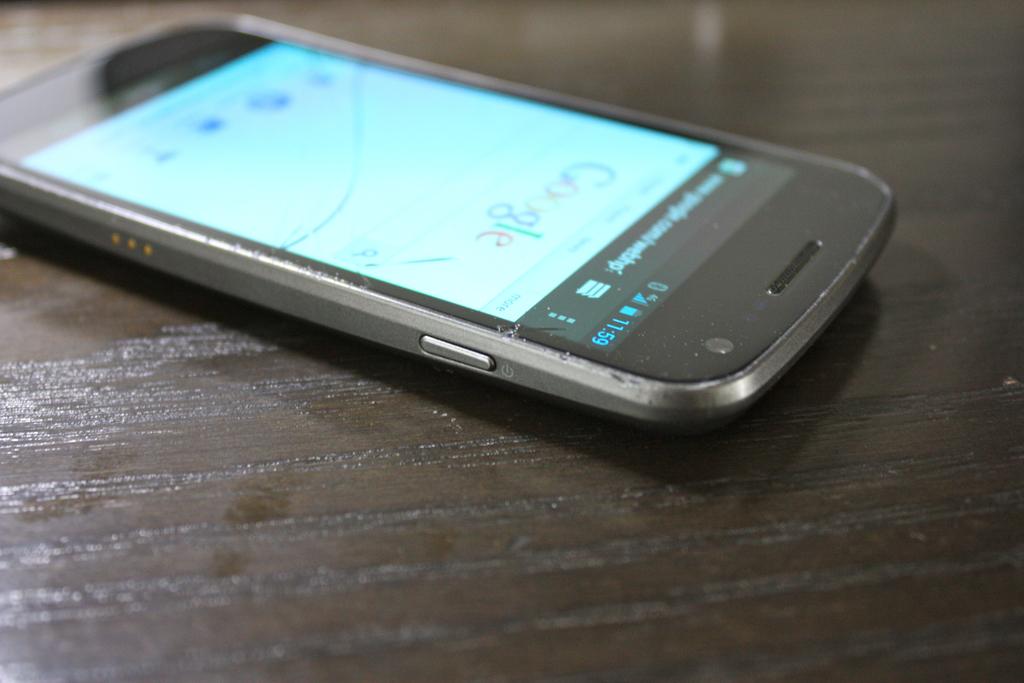What website is this phone on?
Offer a terse response. Google. What is the time on the phone?
Provide a short and direct response. 11:59. 